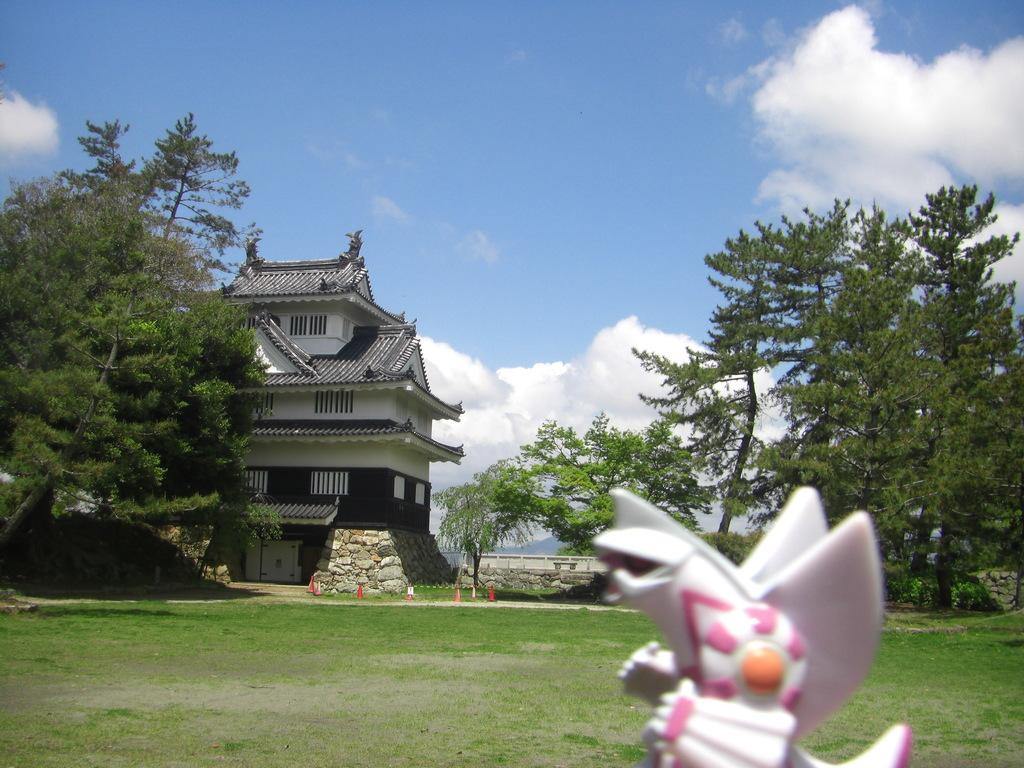What type of structure is visible in the image? There is a building in the image. What natural elements can be seen in the image? There are trees and grass visible in the image. What might be used to direct traffic in the image? Traffic cones are present in the image. What part of the environment is visible in the image? The sky is visible in the image. What atmospheric feature can be seen in the sky? Clouds are present in the sky. What type of silver object can be seen in the image? There is no silver object present in the image. How many dogs are visible in the image? There are no dogs present in the image. 